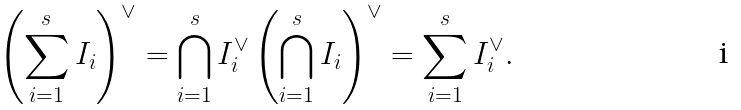Convert formula to latex. <formula><loc_0><loc_0><loc_500><loc_500>\left ( \sum _ { i = 1 } ^ { s } I _ { i } \right ) ^ { \vee } = \bigcap _ { i = 1 } ^ { s } I _ { i } ^ { \vee } \left ( \bigcap _ { i = 1 } ^ { s } I _ { i } \right ) ^ { \vee } = \sum _ { i = 1 } ^ { s } I _ { i } ^ { \vee } .</formula> 